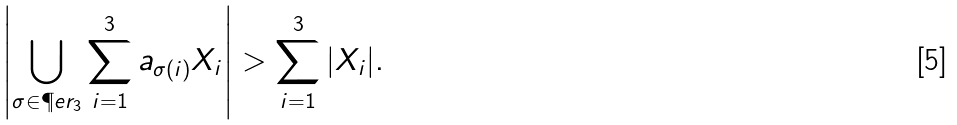Convert formula to latex. <formula><loc_0><loc_0><loc_500><loc_500>\left | \bigcup _ { \sigma \in \P e r _ { 3 } } \sum _ { i = 1 } ^ { 3 } a _ { \sigma ( i ) } X _ { i } \right | > \sum _ { i = 1 } ^ { 3 } | X _ { i } | .</formula> 